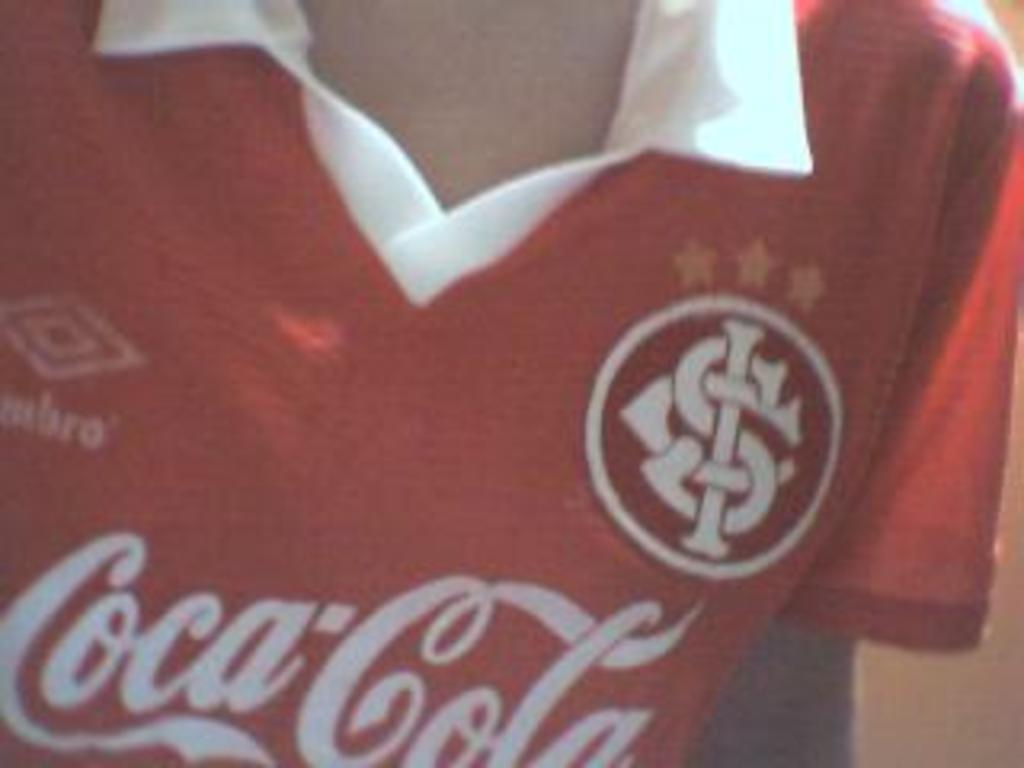What is present in the image? There is a person in the image. What is the person wearing? The person is wearing a red t-shirt. Can you describe the t-shirt further? Yes, there is text on the t-shirt. What type of nail is being used to fix the stove in the image? There is no nail or stove present in the image; it only features a person wearing a red t-shirt with text on it. 